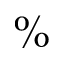<formula> <loc_0><loc_0><loc_500><loc_500>\%</formula> 